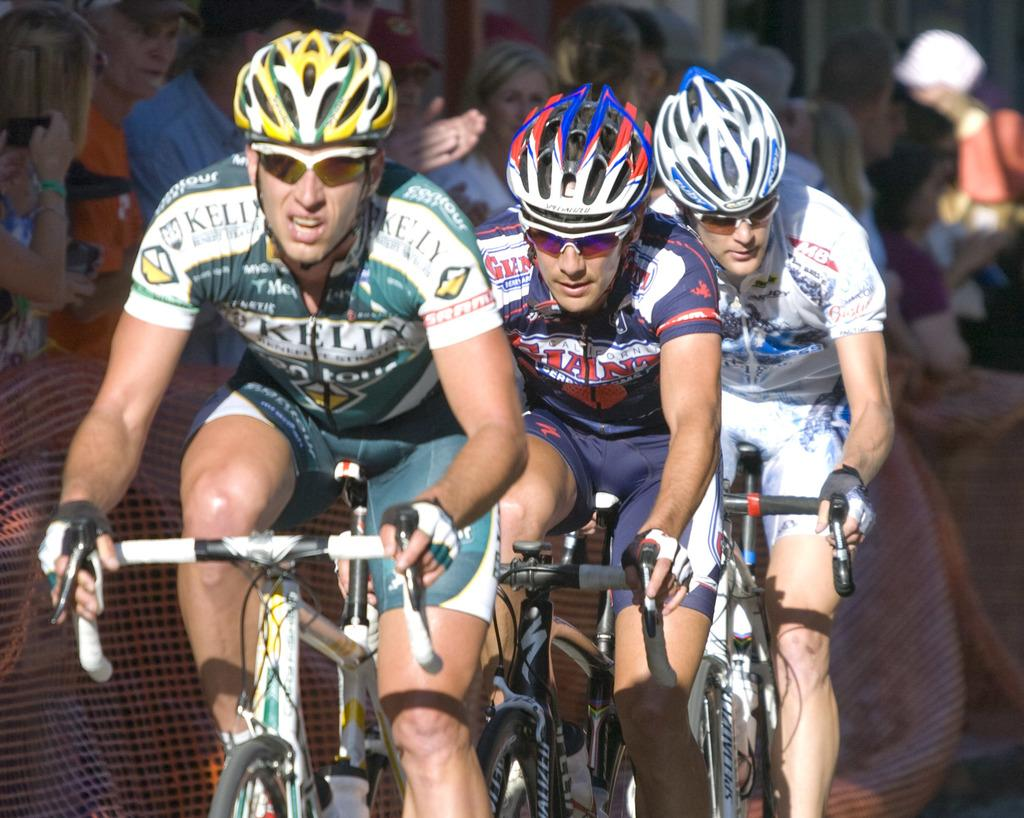How many men are in the image? There are three men in the image. What protective gear are the men wearing? The men are wearing goggles, helmets, and gloves. What activity are the men engaged in? The men are riding bicycles. Can you describe the people in the background of the image? There is a group of people standing in the background of the image. What types of pets can be seen in the image? There are no pets visible in the image. How many houses are present in the image? There is no mention of houses in the image. 